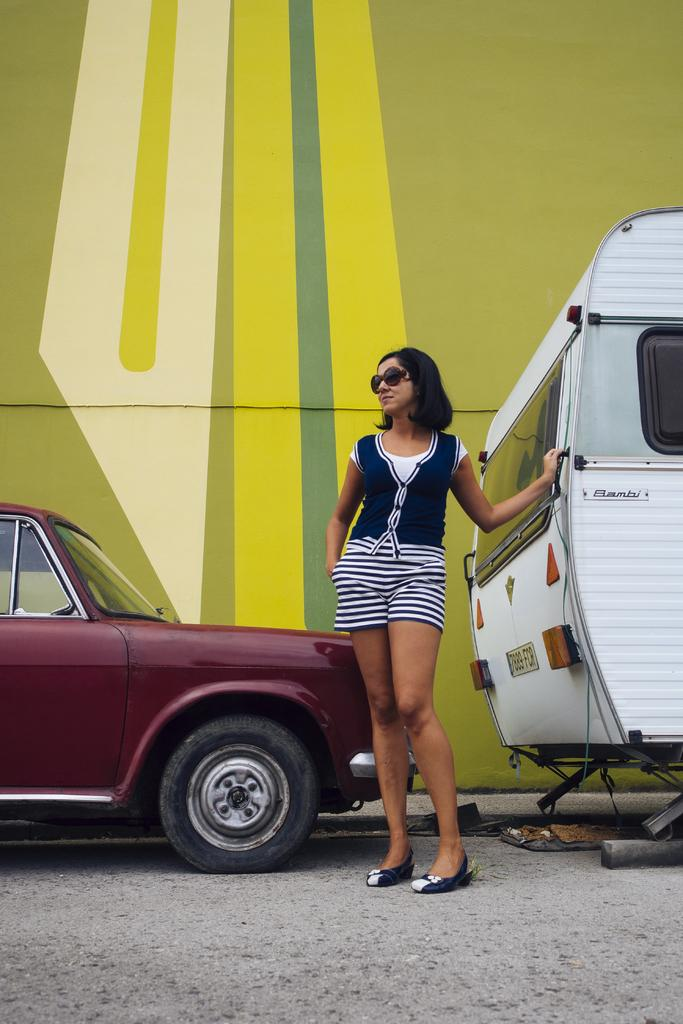Who is the main subject in the image? There is a lady in the image. What is the lady wearing on her face? The lady is wearing goggles. What is the lady's posture in the image? The lady is standing. What can be seen near the lady in the image? There are vehicles near the lady. What is visible in the background of the image? There is a wall in the background of the image. What type of field can be seen in the image? There is no field present in the image; it features a lady wearing goggles, vehicles, and a wall in the background. Is the scene in the image particularly quiet? The level of noise or quietness in the image cannot be determined from the provided facts. 